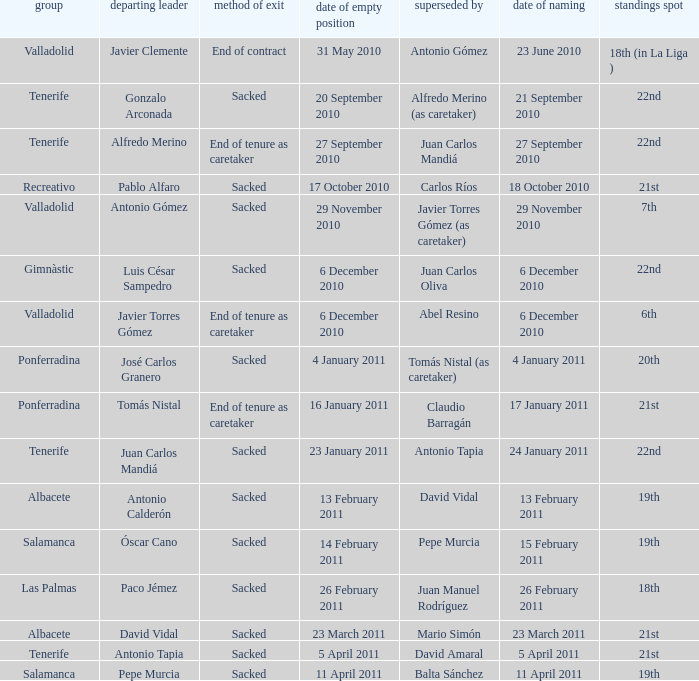What was the appointment date for outgoing manager luis césar sampedro 6 December 2010. 